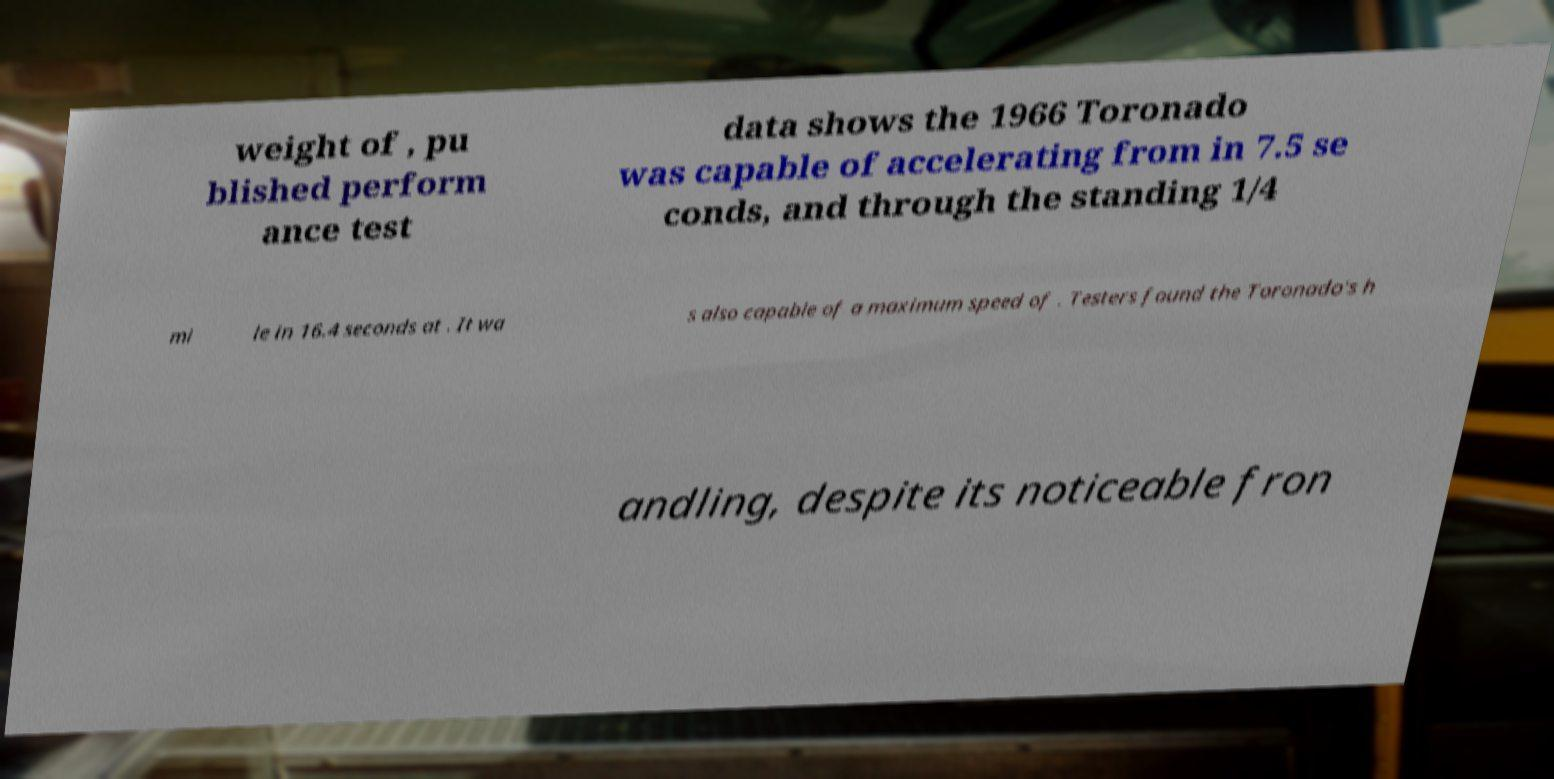Please read and relay the text visible in this image. What does it say? weight of , pu blished perform ance test data shows the 1966 Toronado was capable of accelerating from in 7.5 se conds, and through the standing 1/4 mi le in 16.4 seconds at . It wa s also capable of a maximum speed of . Testers found the Toronado's h andling, despite its noticeable fron 